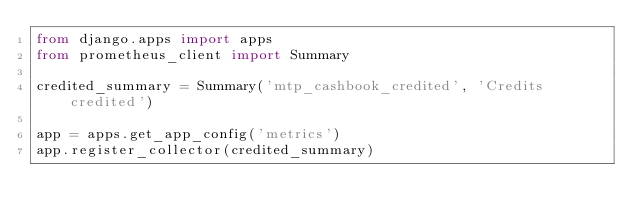<code> <loc_0><loc_0><loc_500><loc_500><_Python_>from django.apps import apps
from prometheus_client import Summary

credited_summary = Summary('mtp_cashbook_credited', 'Credits credited')

app = apps.get_app_config('metrics')
app.register_collector(credited_summary)
</code> 